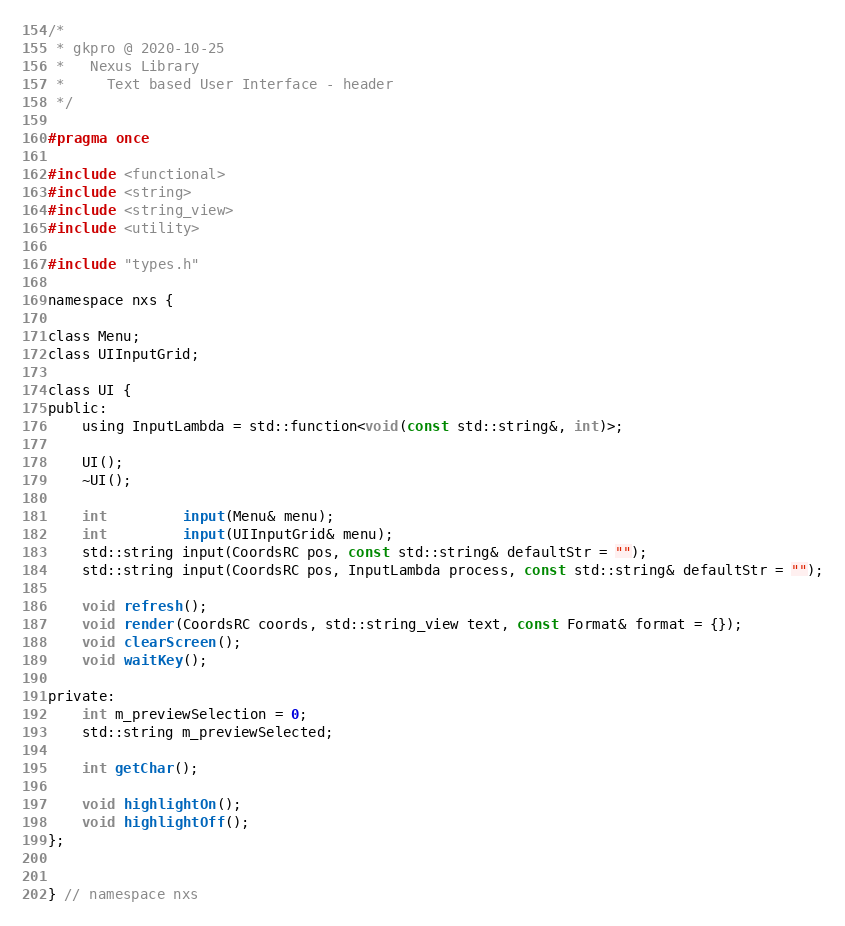<code> <loc_0><loc_0><loc_500><loc_500><_C_>/*
 * gkpro @ 2020-10-25
 *   Nexus Library
 *     Text based User Interface - header
 */

#pragma once

#include <functional>
#include <string>
#include <string_view>
#include <utility>

#include "types.h"

namespace nxs {

class Menu;
class UIInputGrid;

class UI {
public:
    using InputLambda = std::function<void(const std::string&, int)>;

    UI();
    ~UI();

    int         input(Menu& menu);
    int         input(UIInputGrid& menu);
    std::string input(CoordsRC pos, const std::string& defaultStr = "");
    std::string input(CoordsRC pos, InputLambda process, const std::string& defaultStr = "");

    void refresh();
    void render(CoordsRC coords, std::string_view text, const Format& format = {});
    void clearScreen();
    void waitKey();

private:
    int m_previewSelection = 0;
    std::string m_previewSelected;

    int getChar();

    void highlightOn();
    void highlightOff();
};


} // namespace nxs
</code> 